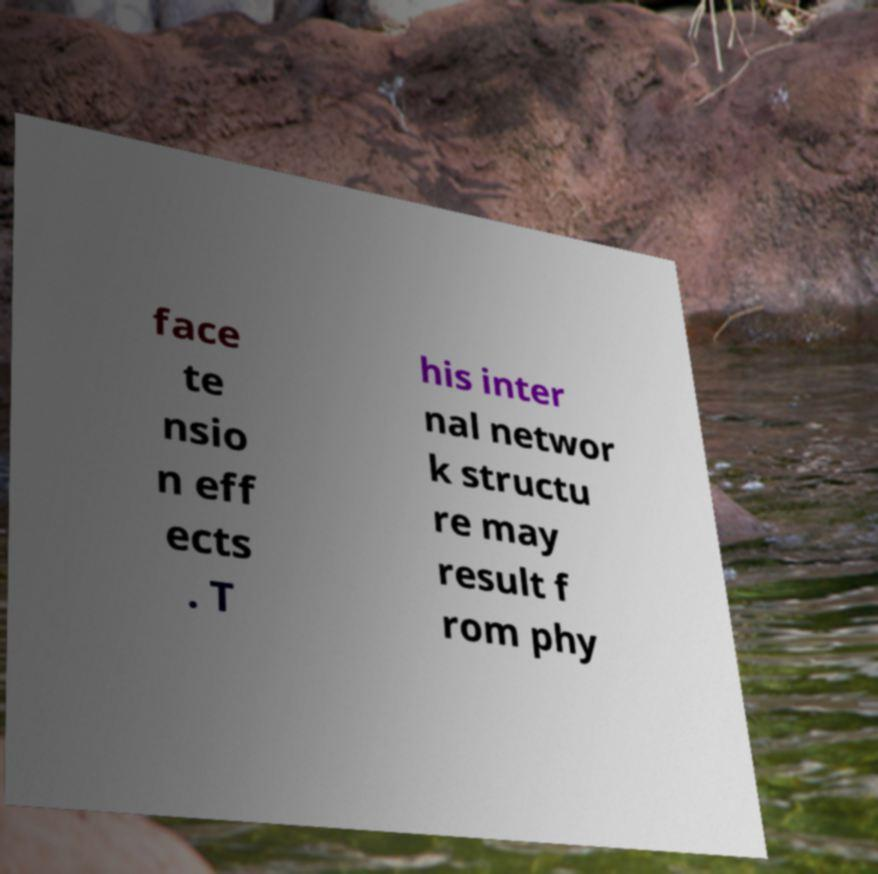What messages or text are displayed in this image? I need them in a readable, typed format. face te nsio n eff ects . T his inter nal networ k structu re may result f rom phy 